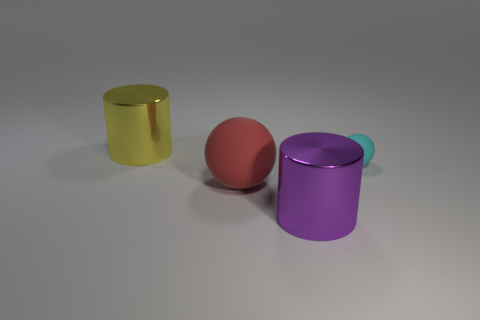What size is the cylinder that is behind the large metallic thing that is in front of the big cylinder that is on the left side of the red rubber ball?
Offer a very short reply. Large. What color is the big metallic thing in front of the large yellow object?
Offer a terse response. Purple. Is the number of cylinders right of the purple metal thing greater than the number of large red balls?
Offer a very short reply. No. There is a object behind the small rubber thing; does it have the same shape as the tiny cyan thing?
Provide a succinct answer. No. How many purple things are either rubber spheres or metallic cylinders?
Keep it short and to the point. 1. Are there more big purple objects than gray metal cylinders?
Offer a terse response. Yes. The other shiny object that is the same size as the purple object is what color?
Ensure brevity in your answer.  Yellow. What number of spheres are either big yellow objects or red objects?
Your answer should be very brief. 1. Does the large purple object have the same shape as the metal object behind the tiny cyan thing?
Provide a succinct answer. Yes. What number of metal cylinders have the same size as the yellow metal object?
Offer a terse response. 1. 